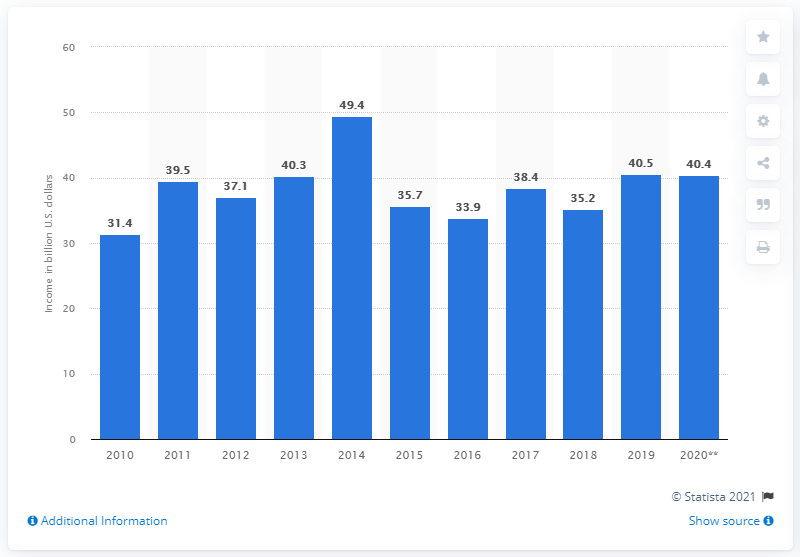Mention a couple of crucial points in this snapshot. The total amount of cash receipts from dairy products at the end of 2020 was 40,400. 